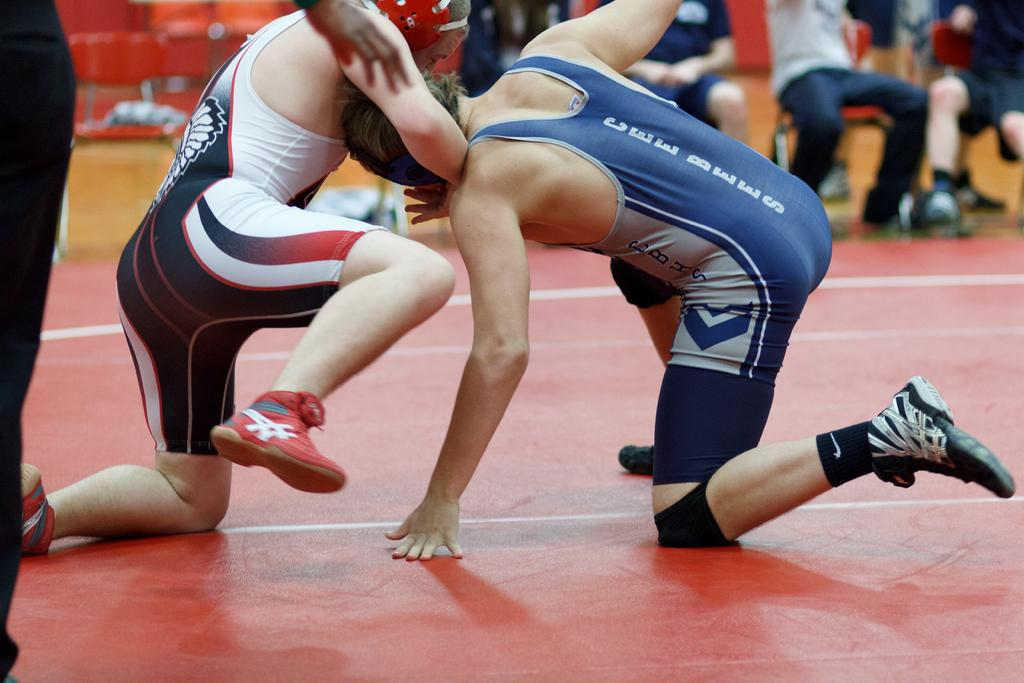<image>
Present a compact description of the photo's key features. A wrestler from the Cee Bees competes in a match. 